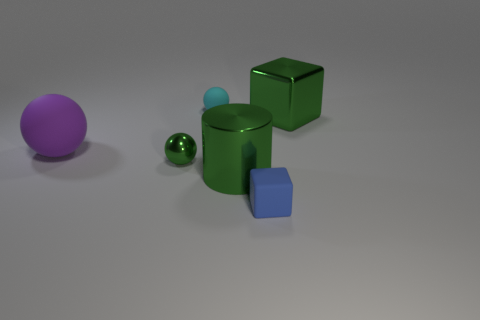Add 3 metal things. How many objects exist? 9 Subtract all cylinders. How many objects are left? 5 Add 5 large green rubber cubes. How many large green rubber cubes exist? 5 Subtract 0 cyan blocks. How many objects are left? 6 Subtract all tiny cyan rubber things. Subtract all blue cubes. How many objects are left? 4 Add 1 cyan spheres. How many cyan spheres are left? 2 